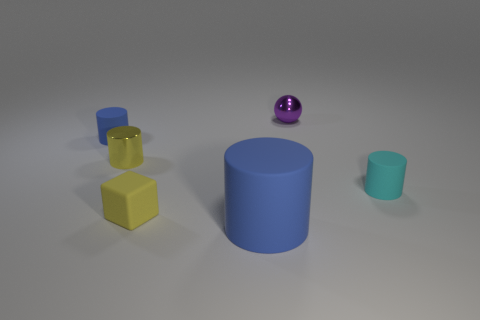Subtract all large blue cylinders. How many cylinders are left? 3 Add 1 tiny cyan things. How many objects exist? 7 Subtract 1 cubes. How many cubes are left? 0 Subtract all yellow cylinders. How many cylinders are left? 3 Subtract all blocks. How many objects are left? 5 Subtract all red balls. How many blue cylinders are left? 2 Add 4 tiny purple shiny objects. How many tiny purple shiny objects exist? 5 Subtract 0 blue blocks. How many objects are left? 6 Subtract all blue balls. Subtract all cyan cubes. How many balls are left? 1 Subtract all tiny cyan matte objects. Subtract all tiny things. How many objects are left? 0 